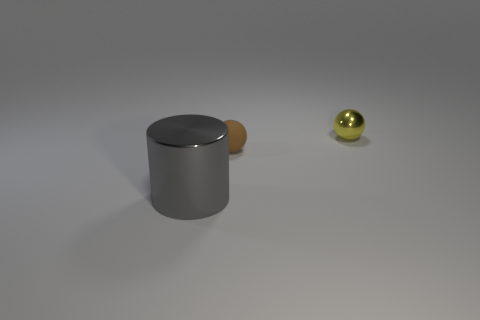Do the tiny sphere that is in front of the yellow metal sphere and the metallic object behind the gray shiny object have the same color?
Your response must be concise. No. What number of objects are left of the brown thing and on the right side of the matte sphere?
Your answer should be very brief. 0. What is the large cylinder made of?
Your response must be concise. Metal. There is a yellow thing that is the same size as the rubber sphere; what shape is it?
Provide a succinct answer. Sphere. Are the small ball left of the yellow object and the small object that is on the right side of the brown rubber sphere made of the same material?
Keep it short and to the point. No. How many big objects are there?
Offer a terse response. 1. What number of big shiny things have the same shape as the matte thing?
Your answer should be compact. 0. Is the small yellow object the same shape as the big gray object?
Your answer should be compact. No. The matte thing is what size?
Provide a succinct answer. Small. What number of brown matte balls are the same size as the metallic ball?
Offer a very short reply. 1. 